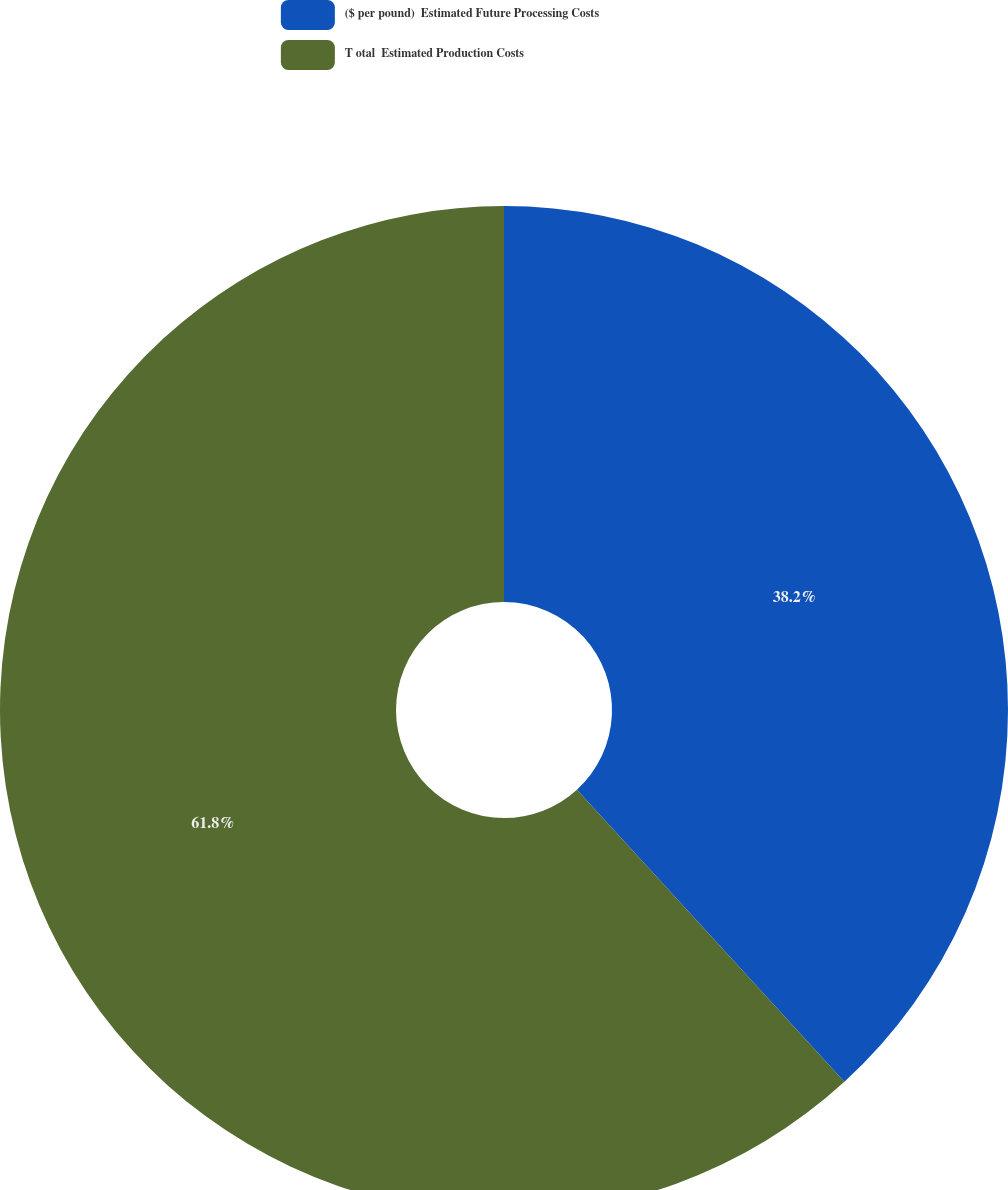Convert chart to OTSL. <chart><loc_0><loc_0><loc_500><loc_500><pie_chart><fcel>($ per pound)  Estimated Future Processing Costs<fcel>T otal  Estimated Production Costs<nl><fcel>38.2%<fcel>61.8%<nl></chart> 